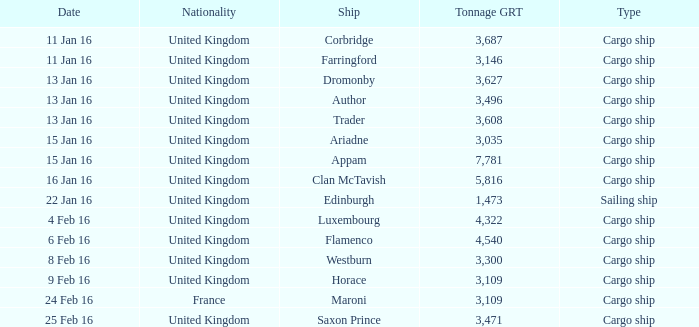What is the most tonnage grt of any ship sunk or captured on 16 jan 16? 5816.0. 